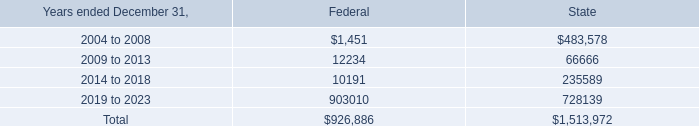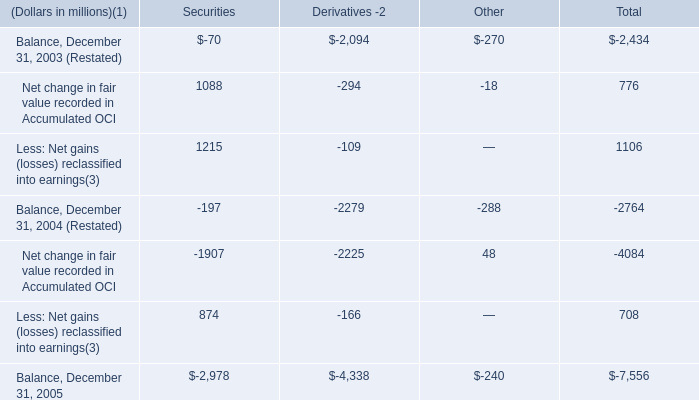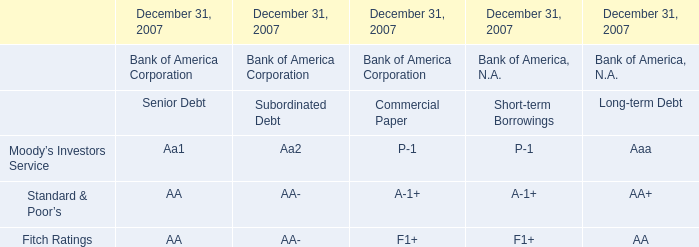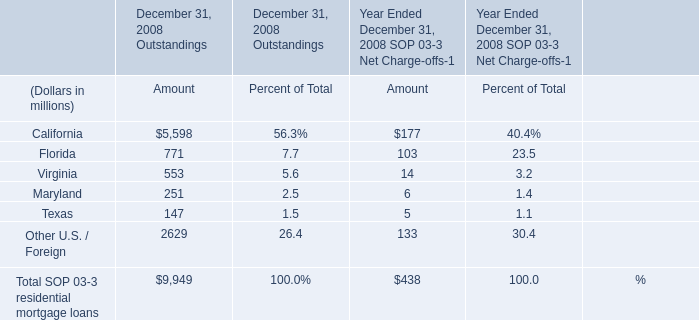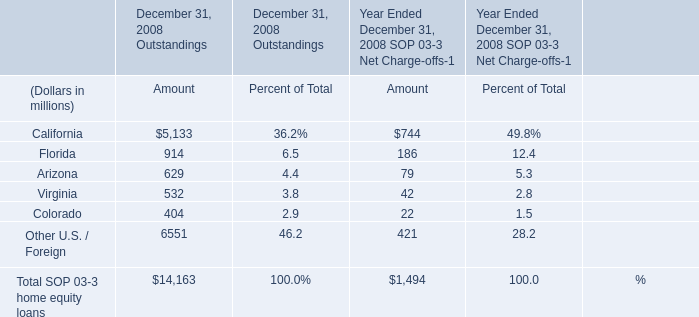How many elements for Amount of December 31, 2008 Outstandings exceed the average of elements? 
Answer: 2. 